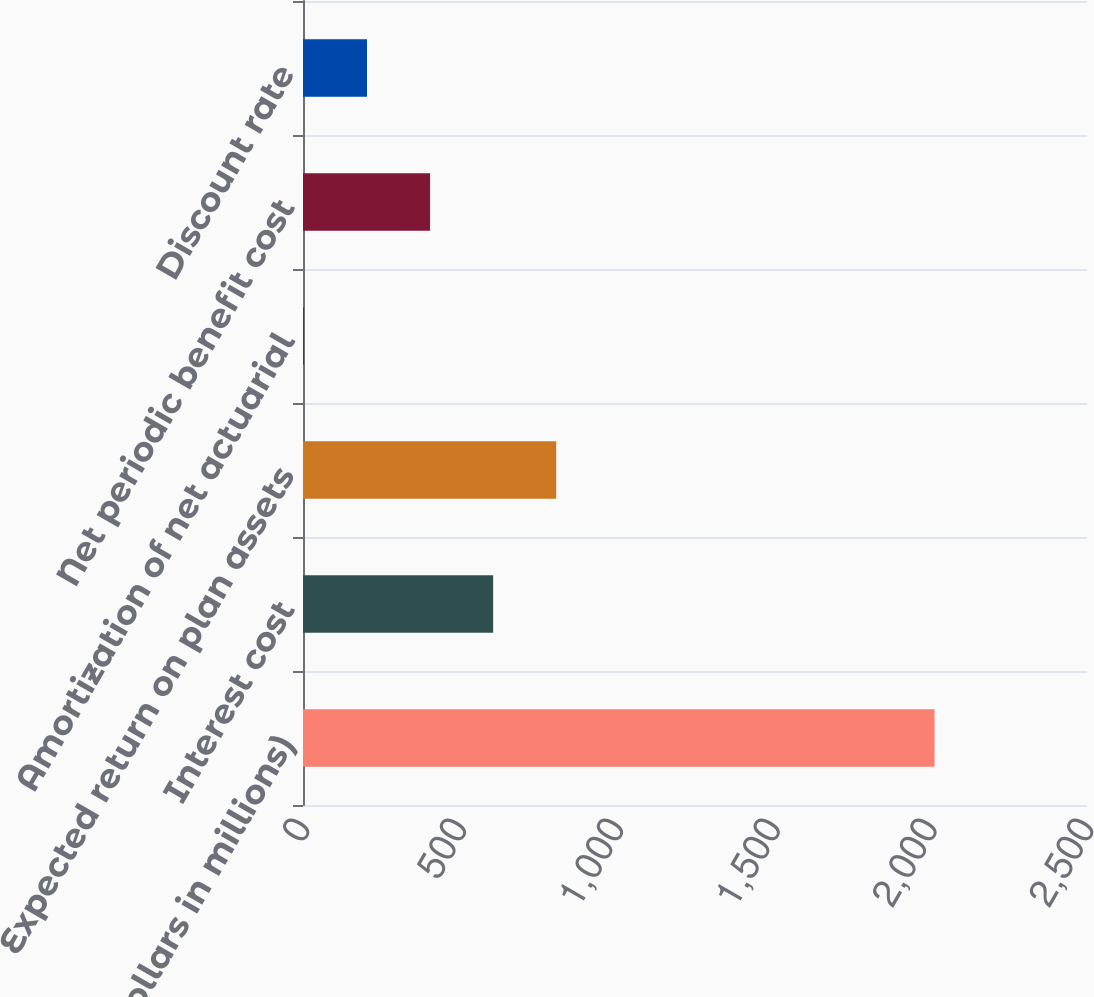Convert chart to OTSL. <chart><loc_0><loc_0><loc_500><loc_500><bar_chart><fcel>(Dollars in millions)<fcel>Interest cost<fcel>Expected return on plan assets<fcel>Amortization of net actuarial<fcel>Net periodic benefit cost<fcel>Discount rate<nl><fcel>2014<fcel>606.3<fcel>807.4<fcel>3<fcel>405.2<fcel>204.1<nl></chart> 